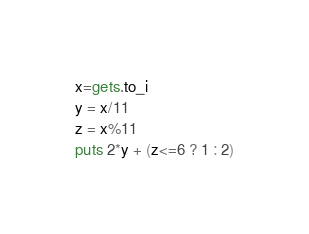Convert code to text. <code><loc_0><loc_0><loc_500><loc_500><_Ruby_>x=gets.to_i
y = x/11
z = x%11
puts 2*y + (z<=6 ? 1 : 2)</code> 